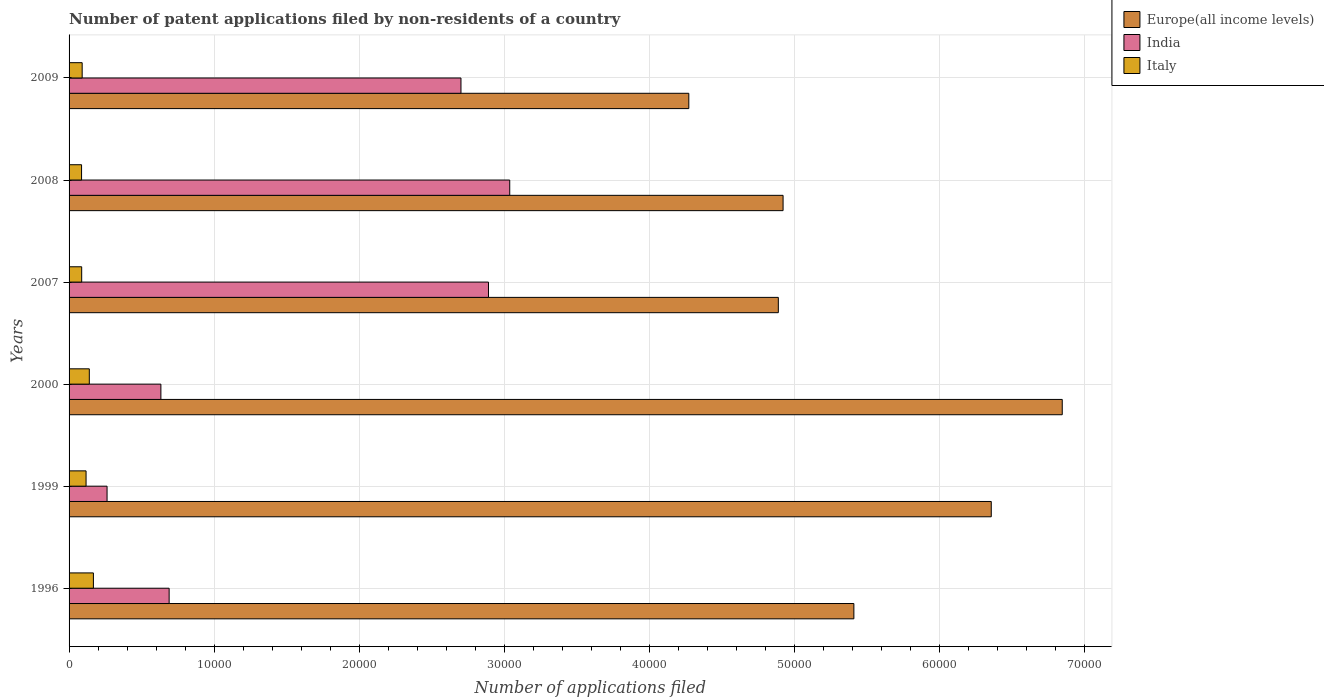Are the number of bars per tick equal to the number of legend labels?
Ensure brevity in your answer.  Yes. Are the number of bars on each tick of the Y-axis equal?
Ensure brevity in your answer.  Yes. What is the number of applications filed in India in 1996?
Provide a succinct answer. 6901. Across all years, what is the maximum number of applications filed in Italy?
Offer a terse response. 1678. Across all years, what is the minimum number of applications filed in Italy?
Provide a short and direct response. 861. What is the total number of applications filed in Italy in the graph?
Make the answer very short. 6880. What is the difference between the number of applications filed in Italy in 1999 and that in 2008?
Keep it short and to the point. 311. What is the difference between the number of applications filed in India in 1996 and the number of applications filed in Italy in 2008?
Provide a succinct answer. 6040. What is the average number of applications filed in India per year?
Keep it short and to the point. 1.70e+04. In the year 2000, what is the difference between the number of applications filed in Italy and number of applications filed in India?
Give a very brief answer. -4936. In how many years, is the number of applications filed in Europe(all income levels) greater than 54000 ?
Keep it short and to the point. 3. What is the ratio of the number of applications filed in Italy in 2000 to that in 2008?
Your response must be concise. 1.62. Is the difference between the number of applications filed in Italy in 2007 and 2009 greater than the difference between the number of applications filed in India in 2007 and 2009?
Provide a succinct answer. No. What is the difference between the highest and the second highest number of applications filed in Europe(all income levels)?
Ensure brevity in your answer.  4895. What is the difference between the highest and the lowest number of applications filed in Europe(all income levels)?
Ensure brevity in your answer.  2.58e+04. Is the sum of the number of applications filed in Europe(all income levels) in 2000 and 2007 greater than the maximum number of applications filed in Italy across all years?
Keep it short and to the point. Yes. What does the 3rd bar from the top in 1999 represents?
Make the answer very short. Europe(all income levels). What does the 1st bar from the bottom in 2008 represents?
Ensure brevity in your answer.  Europe(all income levels). How many bars are there?
Offer a very short reply. 18. Does the graph contain any zero values?
Offer a terse response. No. How are the legend labels stacked?
Make the answer very short. Vertical. What is the title of the graph?
Provide a short and direct response. Number of patent applications filed by non-residents of a country. What is the label or title of the X-axis?
Keep it short and to the point. Number of applications filed. What is the Number of applications filed in Europe(all income levels) in 1996?
Give a very brief answer. 5.41e+04. What is the Number of applications filed of India in 1996?
Offer a very short reply. 6901. What is the Number of applications filed of Italy in 1996?
Provide a succinct answer. 1678. What is the Number of applications filed in Europe(all income levels) in 1999?
Your answer should be very brief. 6.36e+04. What is the Number of applications filed in India in 1999?
Provide a short and direct response. 2620. What is the Number of applications filed of Italy in 1999?
Keep it short and to the point. 1172. What is the Number of applications filed of Europe(all income levels) in 2000?
Give a very brief answer. 6.85e+04. What is the Number of applications filed in India in 2000?
Offer a terse response. 6332. What is the Number of applications filed in Italy in 2000?
Your response must be concise. 1396. What is the Number of applications filed in Europe(all income levels) in 2007?
Your response must be concise. 4.89e+04. What is the Number of applications filed of India in 2007?
Your answer should be very brief. 2.89e+04. What is the Number of applications filed in Italy in 2007?
Provide a short and direct response. 870. What is the Number of applications filed of Europe(all income levels) in 2008?
Provide a succinct answer. 4.92e+04. What is the Number of applications filed in India in 2008?
Offer a very short reply. 3.04e+04. What is the Number of applications filed in Italy in 2008?
Keep it short and to the point. 861. What is the Number of applications filed of Europe(all income levels) in 2009?
Your response must be concise. 4.27e+04. What is the Number of applications filed in India in 2009?
Provide a succinct answer. 2.70e+04. What is the Number of applications filed in Italy in 2009?
Make the answer very short. 903. Across all years, what is the maximum Number of applications filed in Europe(all income levels)?
Keep it short and to the point. 6.85e+04. Across all years, what is the maximum Number of applications filed in India?
Give a very brief answer. 3.04e+04. Across all years, what is the maximum Number of applications filed of Italy?
Provide a short and direct response. 1678. Across all years, what is the minimum Number of applications filed of Europe(all income levels)?
Provide a succinct answer. 4.27e+04. Across all years, what is the minimum Number of applications filed of India?
Your answer should be compact. 2620. Across all years, what is the minimum Number of applications filed in Italy?
Your answer should be very brief. 861. What is the total Number of applications filed in Europe(all income levels) in the graph?
Your answer should be very brief. 3.27e+05. What is the total Number of applications filed of India in the graph?
Offer a terse response. 1.02e+05. What is the total Number of applications filed in Italy in the graph?
Offer a very short reply. 6880. What is the difference between the Number of applications filed in Europe(all income levels) in 1996 and that in 1999?
Your response must be concise. -9474. What is the difference between the Number of applications filed in India in 1996 and that in 1999?
Give a very brief answer. 4281. What is the difference between the Number of applications filed of Italy in 1996 and that in 1999?
Provide a succinct answer. 506. What is the difference between the Number of applications filed in Europe(all income levels) in 1996 and that in 2000?
Provide a succinct answer. -1.44e+04. What is the difference between the Number of applications filed of India in 1996 and that in 2000?
Ensure brevity in your answer.  569. What is the difference between the Number of applications filed in Italy in 1996 and that in 2000?
Make the answer very short. 282. What is the difference between the Number of applications filed in Europe(all income levels) in 1996 and that in 2007?
Your answer should be compact. 5210. What is the difference between the Number of applications filed in India in 1996 and that in 2007?
Your answer should be compact. -2.20e+04. What is the difference between the Number of applications filed of Italy in 1996 and that in 2007?
Offer a terse response. 808. What is the difference between the Number of applications filed in Europe(all income levels) in 1996 and that in 2008?
Your response must be concise. 4882. What is the difference between the Number of applications filed of India in 1996 and that in 2008?
Your answer should be very brief. -2.35e+04. What is the difference between the Number of applications filed in Italy in 1996 and that in 2008?
Offer a terse response. 817. What is the difference between the Number of applications filed of Europe(all income levels) in 1996 and that in 2009?
Offer a terse response. 1.14e+04. What is the difference between the Number of applications filed in India in 1996 and that in 2009?
Your answer should be compact. -2.01e+04. What is the difference between the Number of applications filed of Italy in 1996 and that in 2009?
Keep it short and to the point. 775. What is the difference between the Number of applications filed of Europe(all income levels) in 1999 and that in 2000?
Your answer should be compact. -4895. What is the difference between the Number of applications filed of India in 1999 and that in 2000?
Make the answer very short. -3712. What is the difference between the Number of applications filed in Italy in 1999 and that in 2000?
Your response must be concise. -224. What is the difference between the Number of applications filed of Europe(all income levels) in 1999 and that in 2007?
Ensure brevity in your answer.  1.47e+04. What is the difference between the Number of applications filed of India in 1999 and that in 2007?
Offer a very short reply. -2.63e+04. What is the difference between the Number of applications filed of Italy in 1999 and that in 2007?
Offer a very short reply. 302. What is the difference between the Number of applications filed in Europe(all income levels) in 1999 and that in 2008?
Offer a terse response. 1.44e+04. What is the difference between the Number of applications filed in India in 1999 and that in 2008?
Provide a short and direct response. -2.78e+04. What is the difference between the Number of applications filed in Italy in 1999 and that in 2008?
Offer a very short reply. 311. What is the difference between the Number of applications filed of Europe(all income levels) in 1999 and that in 2009?
Your response must be concise. 2.09e+04. What is the difference between the Number of applications filed in India in 1999 and that in 2009?
Offer a terse response. -2.44e+04. What is the difference between the Number of applications filed of Italy in 1999 and that in 2009?
Ensure brevity in your answer.  269. What is the difference between the Number of applications filed of Europe(all income levels) in 2000 and that in 2007?
Provide a succinct answer. 1.96e+04. What is the difference between the Number of applications filed of India in 2000 and that in 2007?
Provide a succinct answer. -2.26e+04. What is the difference between the Number of applications filed in Italy in 2000 and that in 2007?
Provide a short and direct response. 526. What is the difference between the Number of applications filed in Europe(all income levels) in 2000 and that in 2008?
Give a very brief answer. 1.93e+04. What is the difference between the Number of applications filed of India in 2000 and that in 2008?
Provide a short and direct response. -2.41e+04. What is the difference between the Number of applications filed in Italy in 2000 and that in 2008?
Your answer should be very brief. 535. What is the difference between the Number of applications filed in Europe(all income levels) in 2000 and that in 2009?
Give a very brief answer. 2.58e+04. What is the difference between the Number of applications filed of India in 2000 and that in 2009?
Offer a very short reply. -2.07e+04. What is the difference between the Number of applications filed of Italy in 2000 and that in 2009?
Offer a terse response. 493. What is the difference between the Number of applications filed of Europe(all income levels) in 2007 and that in 2008?
Offer a very short reply. -328. What is the difference between the Number of applications filed in India in 2007 and that in 2008?
Your response must be concise. -1465. What is the difference between the Number of applications filed in Italy in 2007 and that in 2008?
Offer a very short reply. 9. What is the difference between the Number of applications filed of Europe(all income levels) in 2007 and that in 2009?
Give a very brief answer. 6173. What is the difference between the Number of applications filed in India in 2007 and that in 2009?
Keep it short and to the point. 1897. What is the difference between the Number of applications filed in Italy in 2007 and that in 2009?
Provide a succinct answer. -33. What is the difference between the Number of applications filed in Europe(all income levels) in 2008 and that in 2009?
Provide a short and direct response. 6501. What is the difference between the Number of applications filed in India in 2008 and that in 2009?
Keep it short and to the point. 3362. What is the difference between the Number of applications filed in Italy in 2008 and that in 2009?
Your response must be concise. -42. What is the difference between the Number of applications filed in Europe(all income levels) in 1996 and the Number of applications filed in India in 1999?
Your answer should be very brief. 5.15e+04. What is the difference between the Number of applications filed in Europe(all income levels) in 1996 and the Number of applications filed in Italy in 1999?
Make the answer very short. 5.29e+04. What is the difference between the Number of applications filed in India in 1996 and the Number of applications filed in Italy in 1999?
Your answer should be compact. 5729. What is the difference between the Number of applications filed of Europe(all income levels) in 1996 and the Number of applications filed of India in 2000?
Offer a terse response. 4.78e+04. What is the difference between the Number of applications filed of Europe(all income levels) in 1996 and the Number of applications filed of Italy in 2000?
Ensure brevity in your answer.  5.27e+04. What is the difference between the Number of applications filed in India in 1996 and the Number of applications filed in Italy in 2000?
Your response must be concise. 5505. What is the difference between the Number of applications filed in Europe(all income levels) in 1996 and the Number of applications filed in India in 2007?
Make the answer very short. 2.52e+04. What is the difference between the Number of applications filed in Europe(all income levels) in 1996 and the Number of applications filed in Italy in 2007?
Ensure brevity in your answer.  5.32e+04. What is the difference between the Number of applications filed of India in 1996 and the Number of applications filed of Italy in 2007?
Offer a terse response. 6031. What is the difference between the Number of applications filed in Europe(all income levels) in 1996 and the Number of applications filed in India in 2008?
Your response must be concise. 2.37e+04. What is the difference between the Number of applications filed in Europe(all income levels) in 1996 and the Number of applications filed in Italy in 2008?
Give a very brief answer. 5.33e+04. What is the difference between the Number of applications filed of India in 1996 and the Number of applications filed of Italy in 2008?
Ensure brevity in your answer.  6040. What is the difference between the Number of applications filed in Europe(all income levels) in 1996 and the Number of applications filed in India in 2009?
Your answer should be compact. 2.71e+04. What is the difference between the Number of applications filed of Europe(all income levels) in 1996 and the Number of applications filed of Italy in 2009?
Make the answer very short. 5.32e+04. What is the difference between the Number of applications filed in India in 1996 and the Number of applications filed in Italy in 2009?
Ensure brevity in your answer.  5998. What is the difference between the Number of applications filed in Europe(all income levels) in 1999 and the Number of applications filed in India in 2000?
Ensure brevity in your answer.  5.73e+04. What is the difference between the Number of applications filed in Europe(all income levels) in 1999 and the Number of applications filed in Italy in 2000?
Ensure brevity in your answer.  6.22e+04. What is the difference between the Number of applications filed of India in 1999 and the Number of applications filed of Italy in 2000?
Provide a succinct answer. 1224. What is the difference between the Number of applications filed of Europe(all income levels) in 1999 and the Number of applications filed of India in 2007?
Offer a terse response. 3.47e+04. What is the difference between the Number of applications filed in Europe(all income levels) in 1999 and the Number of applications filed in Italy in 2007?
Provide a succinct answer. 6.27e+04. What is the difference between the Number of applications filed of India in 1999 and the Number of applications filed of Italy in 2007?
Make the answer very short. 1750. What is the difference between the Number of applications filed in Europe(all income levels) in 1999 and the Number of applications filed in India in 2008?
Provide a short and direct response. 3.32e+04. What is the difference between the Number of applications filed in Europe(all income levels) in 1999 and the Number of applications filed in Italy in 2008?
Make the answer very short. 6.27e+04. What is the difference between the Number of applications filed in India in 1999 and the Number of applications filed in Italy in 2008?
Provide a short and direct response. 1759. What is the difference between the Number of applications filed of Europe(all income levels) in 1999 and the Number of applications filed of India in 2009?
Keep it short and to the point. 3.66e+04. What is the difference between the Number of applications filed in Europe(all income levels) in 1999 and the Number of applications filed in Italy in 2009?
Your response must be concise. 6.27e+04. What is the difference between the Number of applications filed in India in 1999 and the Number of applications filed in Italy in 2009?
Give a very brief answer. 1717. What is the difference between the Number of applications filed of Europe(all income levels) in 2000 and the Number of applications filed of India in 2007?
Give a very brief answer. 3.96e+04. What is the difference between the Number of applications filed in Europe(all income levels) in 2000 and the Number of applications filed in Italy in 2007?
Your answer should be very brief. 6.76e+04. What is the difference between the Number of applications filed of India in 2000 and the Number of applications filed of Italy in 2007?
Your answer should be compact. 5462. What is the difference between the Number of applications filed in Europe(all income levels) in 2000 and the Number of applications filed in India in 2008?
Keep it short and to the point. 3.81e+04. What is the difference between the Number of applications filed in Europe(all income levels) in 2000 and the Number of applications filed in Italy in 2008?
Make the answer very short. 6.76e+04. What is the difference between the Number of applications filed of India in 2000 and the Number of applications filed of Italy in 2008?
Your answer should be compact. 5471. What is the difference between the Number of applications filed of Europe(all income levels) in 2000 and the Number of applications filed of India in 2009?
Offer a terse response. 4.15e+04. What is the difference between the Number of applications filed in Europe(all income levels) in 2000 and the Number of applications filed in Italy in 2009?
Your response must be concise. 6.76e+04. What is the difference between the Number of applications filed of India in 2000 and the Number of applications filed of Italy in 2009?
Your response must be concise. 5429. What is the difference between the Number of applications filed of Europe(all income levels) in 2007 and the Number of applications filed of India in 2008?
Make the answer very short. 1.85e+04. What is the difference between the Number of applications filed in Europe(all income levels) in 2007 and the Number of applications filed in Italy in 2008?
Your answer should be compact. 4.80e+04. What is the difference between the Number of applications filed of India in 2007 and the Number of applications filed of Italy in 2008?
Your response must be concise. 2.81e+04. What is the difference between the Number of applications filed in Europe(all income levels) in 2007 and the Number of applications filed in India in 2009?
Provide a succinct answer. 2.19e+04. What is the difference between the Number of applications filed in Europe(all income levels) in 2007 and the Number of applications filed in Italy in 2009?
Your response must be concise. 4.80e+04. What is the difference between the Number of applications filed of India in 2007 and the Number of applications filed of Italy in 2009?
Provide a succinct answer. 2.80e+04. What is the difference between the Number of applications filed of Europe(all income levels) in 2008 and the Number of applications filed of India in 2009?
Provide a short and direct response. 2.22e+04. What is the difference between the Number of applications filed in Europe(all income levels) in 2008 and the Number of applications filed in Italy in 2009?
Give a very brief answer. 4.83e+04. What is the difference between the Number of applications filed of India in 2008 and the Number of applications filed of Italy in 2009?
Offer a terse response. 2.95e+04. What is the average Number of applications filed in Europe(all income levels) per year?
Your answer should be compact. 5.45e+04. What is the average Number of applications filed of India per year?
Your answer should be compact. 1.70e+04. What is the average Number of applications filed of Italy per year?
Provide a short and direct response. 1146.67. In the year 1996, what is the difference between the Number of applications filed in Europe(all income levels) and Number of applications filed in India?
Offer a very short reply. 4.72e+04. In the year 1996, what is the difference between the Number of applications filed of Europe(all income levels) and Number of applications filed of Italy?
Ensure brevity in your answer.  5.24e+04. In the year 1996, what is the difference between the Number of applications filed of India and Number of applications filed of Italy?
Ensure brevity in your answer.  5223. In the year 1999, what is the difference between the Number of applications filed in Europe(all income levels) and Number of applications filed in India?
Your answer should be compact. 6.10e+04. In the year 1999, what is the difference between the Number of applications filed in Europe(all income levels) and Number of applications filed in Italy?
Your answer should be compact. 6.24e+04. In the year 1999, what is the difference between the Number of applications filed in India and Number of applications filed in Italy?
Offer a very short reply. 1448. In the year 2000, what is the difference between the Number of applications filed of Europe(all income levels) and Number of applications filed of India?
Ensure brevity in your answer.  6.22e+04. In the year 2000, what is the difference between the Number of applications filed of Europe(all income levels) and Number of applications filed of Italy?
Provide a short and direct response. 6.71e+04. In the year 2000, what is the difference between the Number of applications filed in India and Number of applications filed in Italy?
Keep it short and to the point. 4936. In the year 2007, what is the difference between the Number of applications filed in Europe(all income levels) and Number of applications filed in India?
Offer a terse response. 2.00e+04. In the year 2007, what is the difference between the Number of applications filed in Europe(all income levels) and Number of applications filed in Italy?
Your response must be concise. 4.80e+04. In the year 2007, what is the difference between the Number of applications filed in India and Number of applications filed in Italy?
Give a very brief answer. 2.81e+04. In the year 2008, what is the difference between the Number of applications filed of Europe(all income levels) and Number of applications filed of India?
Your response must be concise. 1.88e+04. In the year 2008, what is the difference between the Number of applications filed in Europe(all income levels) and Number of applications filed in Italy?
Keep it short and to the point. 4.84e+04. In the year 2008, what is the difference between the Number of applications filed of India and Number of applications filed of Italy?
Give a very brief answer. 2.95e+04. In the year 2009, what is the difference between the Number of applications filed in Europe(all income levels) and Number of applications filed in India?
Make the answer very short. 1.57e+04. In the year 2009, what is the difference between the Number of applications filed in Europe(all income levels) and Number of applications filed in Italy?
Provide a succinct answer. 4.18e+04. In the year 2009, what is the difference between the Number of applications filed in India and Number of applications filed in Italy?
Provide a short and direct response. 2.61e+04. What is the ratio of the Number of applications filed in Europe(all income levels) in 1996 to that in 1999?
Offer a very short reply. 0.85. What is the ratio of the Number of applications filed in India in 1996 to that in 1999?
Your answer should be compact. 2.63. What is the ratio of the Number of applications filed in Italy in 1996 to that in 1999?
Your response must be concise. 1.43. What is the ratio of the Number of applications filed in Europe(all income levels) in 1996 to that in 2000?
Provide a short and direct response. 0.79. What is the ratio of the Number of applications filed of India in 1996 to that in 2000?
Keep it short and to the point. 1.09. What is the ratio of the Number of applications filed in Italy in 1996 to that in 2000?
Offer a very short reply. 1.2. What is the ratio of the Number of applications filed of Europe(all income levels) in 1996 to that in 2007?
Give a very brief answer. 1.11. What is the ratio of the Number of applications filed of India in 1996 to that in 2007?
Offer a terse response. 0.24. What is the ratio of the Number of applications filed in Italy in 1996 to that in 2007?
Make the answer very short. 1.93. What is the ratio of the Number of applications filed of Europe(all income levels) in 1996 to that in 2008?
Make the answer very short. 1.1. What is the ratio of the Number of applications filed of India in 1996 to that in 2008?
Make the answer very short. 0.23. What is the ratio of the Number of applications filed in Italy in 1996 to that in 2008?
Keep it short and to the point. 1.95. What is the ratio of the Number of applications filed of Europe(all income levels) in 1996 to that in 2009?
Your response must be concise. 1.27. What is the ratio of the Number of applications filed of India in 1996 to that in 2009?
Make the answer very short. 0.26. What is the ratio of the Number of applications filed in Italy in 1996 to that in 2009?
Provide a succinct answer. 1.86. What is the ratio of the Number of applications filed in Europe(all income levels) in 1999 to that in 2000?
Make the answer very short. 0.93. What is the ratio of the Number of applications filed in India in 1999 to that in 2000?
Offer a very short reply. 0.41. What is the ratio of the Number of applications filed of Italy in 1999 to that in 2000?
Give a very brief answer. 0.84. What is the ratio of the Number of applications filed of Europe(all income levels) in 1999 to that in 2007?
Provide a short and direct response. 1.3. What is the ratio of the Number of applications filed in India in 1999 to that in 2007?
Your answer should be very brief. 0.09. What is the ratio of the Number of applications filed of Italy in 1999 to that in 2007?
Make the answer very short. 1.35. What is the ratio of the Number of applications filed of Europe(all income levels) in 1999 to that in 2008?
Provide a succinct answer. 1.29. What is the ratio of the Number of applications filed in India in 1999 to that in 2008?
Offer a very short reply. 0.09. What is the ratio of the Number of applications filed of Italy in 1999 to that in 2008?
Give a very brief answer. 1.36. What is the ratio of the Number of applications filed of Europe(all income levels) in 1999 to that in 2009?
Make the answer very short. 1.49. What is the ratio of the Number of applications filed of India in 1999 to that in 2009?
Offer a terse response. 0.1. What is the ratio of the Number of applications filed of Italy in 1999 to that in 2009?
Offer a terse response. 1.3. What is the ratio of the Number of applications filed in Europe(all income levels) in 2000 to that in 2007?
Provide a short and direct response. 1.4. What is the ratio of the Number of applications filed in India in 2000 to that in 2007?
Give a very brief answer. 0.22. What is the ratio of the Number of applications filed in Italy in 2000 to that in 2007?
Your response must be concise. 1.6. What is the ratio of the Number of applications filed of Europe(all income levels) in 2000 to that in 2008?
Provide a short and direct response. 1.39. What is the ratio of the Number of applications filed of India in 2000 to that in 2008?
Offer a very short reply. 0.21. What is the ratio of the Number of applications filed in Italy in 2000 to that in 2008?
Offer a terse response. 1.62. What is the ratio of the Number of applications filed in Europe(all income levels) in 2000 to that in 2009?
Give a very brief answer. 1.6. What is the ratio of the Number of applications filed of India in 2000 to that in 2009?
Provide a succinct answer. 0.23. What is the ratio of the Number of applications filed in Italy in 2000 to that in 2009?
Your response must be concise. 1.55. What is the ratio of the Number of applications filed in Europe(all income levels) in 2007 to that in 2008?
Give a very brief answer. 0.99. What is the ratio of the Number of applications filed in India in 2007 to that in 2008?
Your response must be concise. 0.95. What is the ratio of the Number of applications filed in Italy in 2007 to that in 2008?
Provide a short and direct response. 1.01. What is the ratio of the Number of applications filed in Europe(all income levels) in 2007 to that in 2009?
Offer a very short reply. 1.14. What is the ratio of the Number of applications filed of India in 2007 to that in 2009?
Your answer should be compact. 1.07. What is the ratio of the Number of applications filed in Italy in 2007 to that in 2009?
Provide a short and direct response. 0.96. What is the ratio of the Number of applications filed in Europe(all income levels) in 2008 to that in 2009?
Keep it short and to the point. 1.15. What is the ratio of the Number of applications filed of India in 2008 to that in 2009?
Keep it short and to the point. 1.12. What is the ratio of the Number of applications filed in Italy in 2008 to that in 2009?
Provide a succinct answer. 0.95. What is the difference between the highest and the second highest Number of applications filed in Europe(all income levels)?
Keep it short and to the point. 4895. What is the difference between the highest and the second highest Number of applications filed of India?
Your answer should be compact. 1465. What is the difference between the highest and the second highest Number of applications filed in Italy?
Your answer should be very brief. 282. What is the difference between the highest and the lowest Number of applications filed in Europe(all income levels)?
Your answer should be compact. 2.58e+04. What is the difference between the highest and the lowest Number of applications filed of India?
Keep it short and to the point. 2.78e+04. What is the difference between the highest and the lowest Number of applications filed of Italy?
Your response must be concise. 817. 